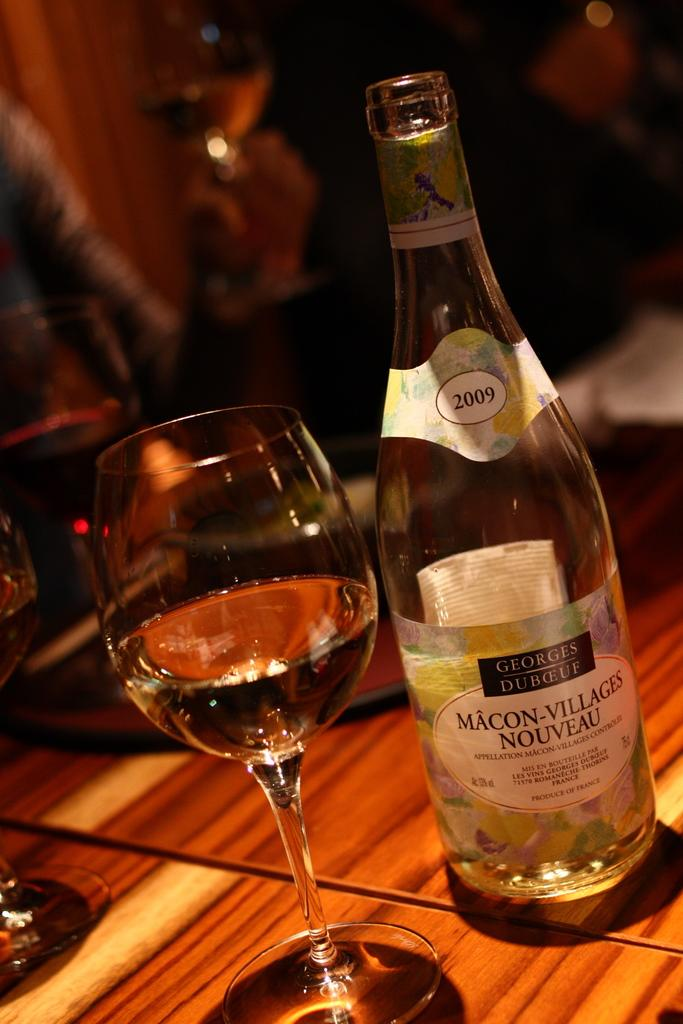What is on the table in the image? There is a wine bottle and a glass on the table in the image. Where is the wine bottle located on the table? The wine bottle is on the right side of the table. Where is the glass located on the table? The glass is on the right side of the table. What is inside the wine bottle and the glass? Both the wine bottle and the glass contain wine. Can you see any visible veins on the wine bottle in the image? There are no visible veins on the wine bottle in the image, as it is an inanimate object and does not have veins. 